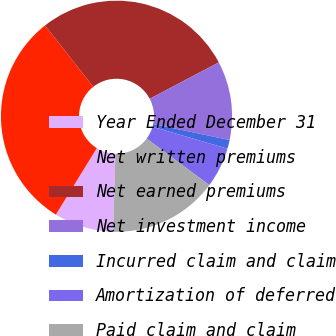<chart> <loc_0><loc_0><loc_500><loc_500><pie_chart><fcel>Year Ended December 31<fcel>Net written premiums<fcel>Net earned premiums<fcel>Net investment income<fcel>Incurred claim and claim<fcel>Amortization of deferred<fcel>Paid claim and claim<nl><fcel>8.33%<fcel>30.59%<fcel>27.9%<fcel>11.02%<fcel>1.22%<fcel>5.64%<fcel>15.3%<nl></chart> 